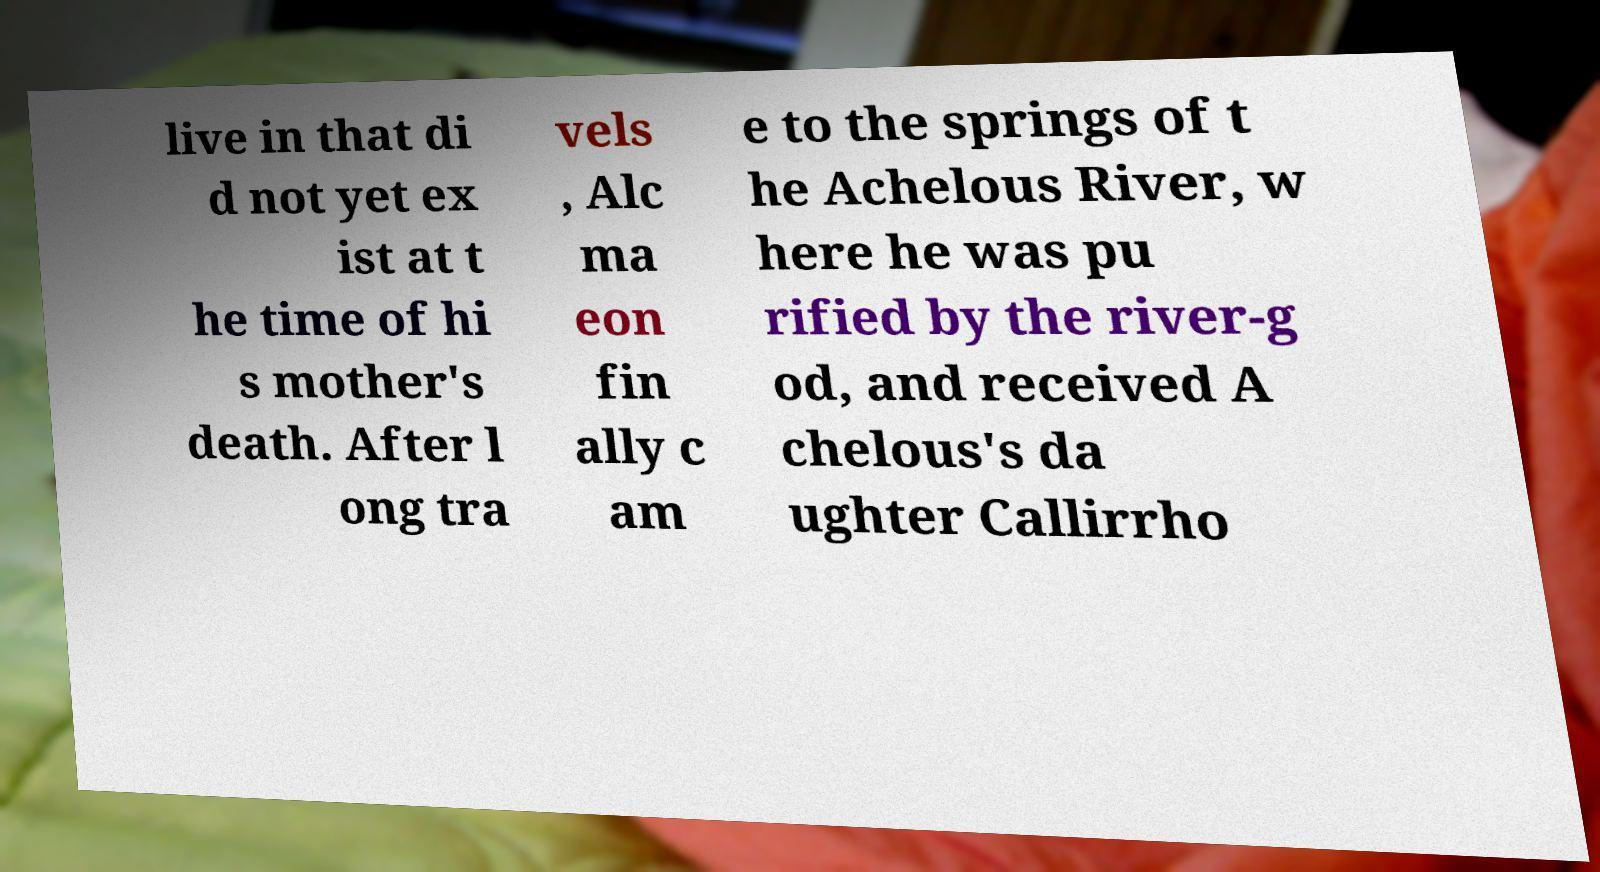Can you read and provide the text displayed in the image?This photo seems to have some interesting text. Can you extract and type it out for me? live in that di d not yet ex ist at t he time of hi s mother's death. After l ong tra vels , Alc ma eon fin ally c am e to the springs of t he Achelous River, w here he was pu rified by the river-g od, and received A chelous's da ughter Callirrho 